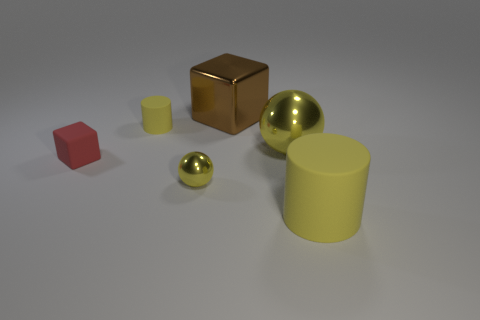If these objects represent real-world items, what could their uses be? If we were to imagine these objects in a real-world context, the cube might be a stylish modern paperweight or an ornamental object. The yellow cylinders could serve as simplistic containers or pencil holders. The spheres, due to their metallic sheen, might be decorative elements or perhaps precise ball bearings in industrial machinery, depending on their actual size and material. Each object's utilitarian function could vary widely based on its scale and composition. 